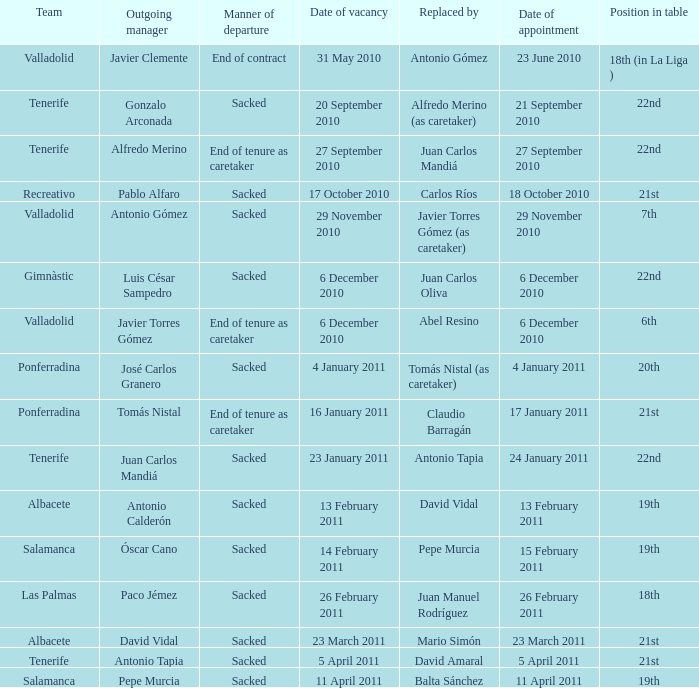What was the appointment date for outgoing manager luis césar sampedro 6 December 2010. 